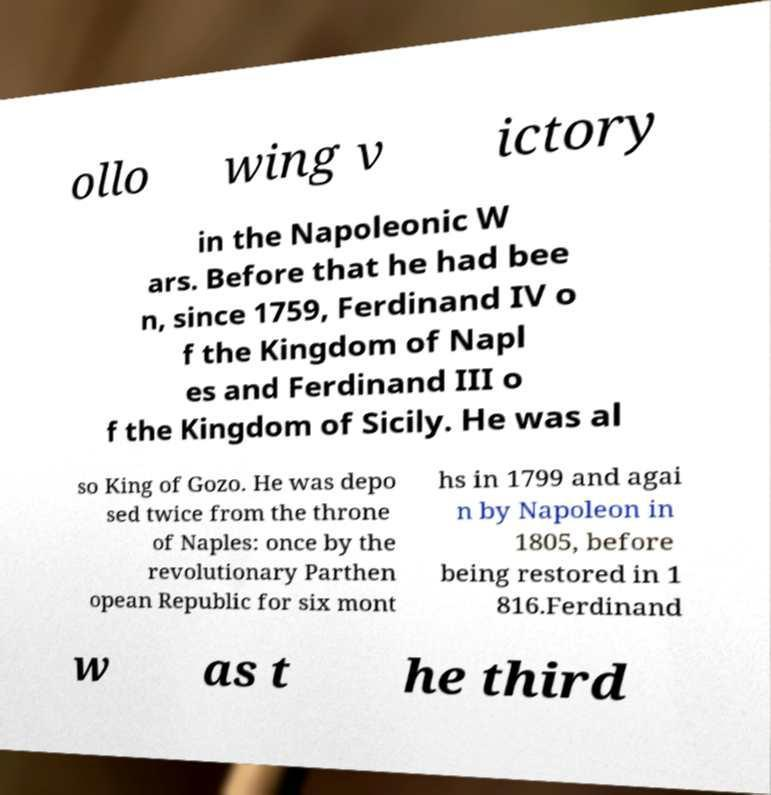What messages or text are displayed in this image? I need them in a readable, typed format. ollo wing v ictory in the Napoleonic W ars. Before that he had bee n, since 1759, Ferdinand IV o f the Kingdom of Napl es and Ferdinand III o f the Kingdom of Sicily. He was al so King of Gozo. He was depo sed twice from the throne of Naples: once by the revolutionary Parthen opean Republic for six mont hs in 1799 and agai n by Napoleon in 1805, before being restored in 1 816.Ferdinand w as t he third 